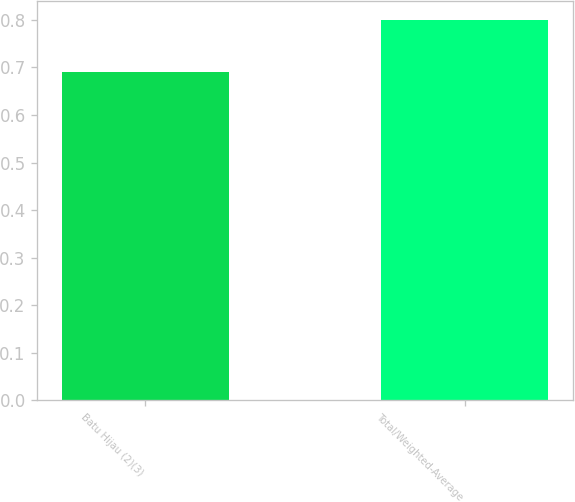Convert chart to OTSL. <chart><loc_0><loc_0><loc_500><loc_500><bar_chart><fcel>Batu Hijau (2)(3)<fcel>Total/Weighted-Average<nl><fcel>0.69<fcel>0.8<nl></chart> 